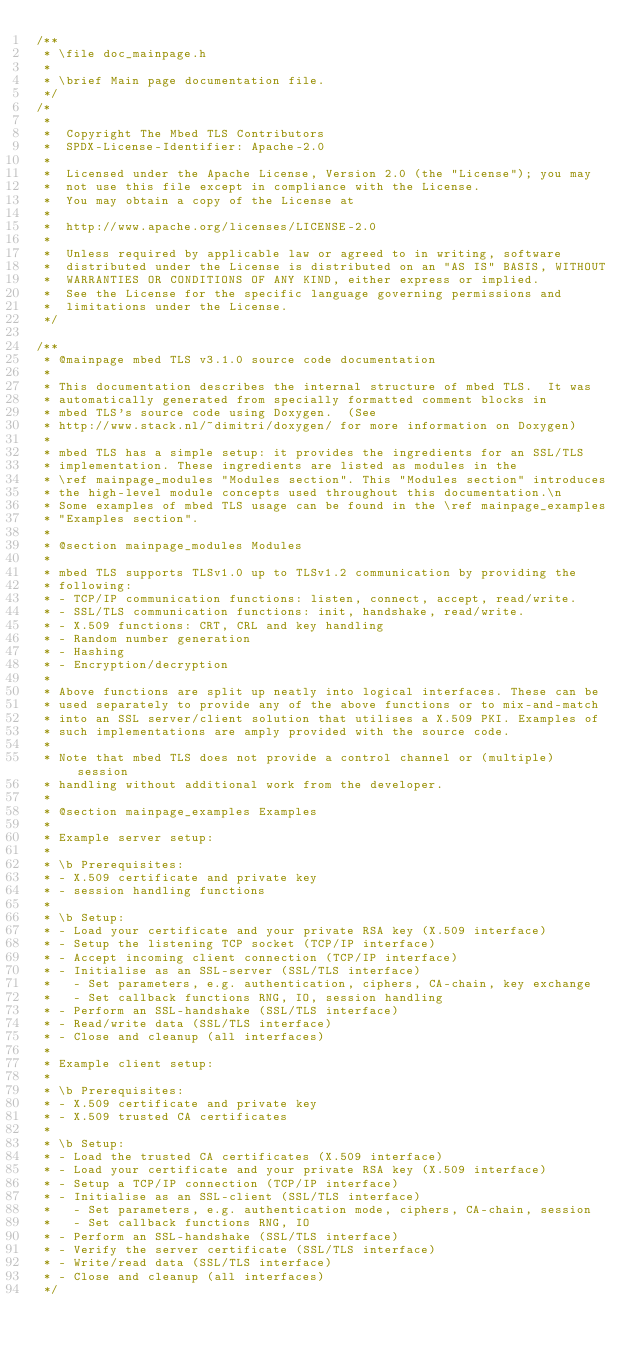Convert code to text. <code><loc_0><loc_0><loc_500><loc_500><_C_>/**
 * \file doc_mainpage.h
 *
 * \brief Main page documentation file.
 */
/*
 *
 *  Copyright The Mbed TLS Contributors
 *  SPDX-License-Identifier: Apache-2.0
 *
 *  Licensed under the Apache License, Version 2.0 (the "License"); you may
 *  not use this file except in compliance with the License.
 *  You may obtain a copy of the License at
 *
 *  http://www.apache.org/licenses/LICENSE-2.0
 *
 *  Unless required by applicable law or agreed to in writing, software
 *  distributed under the License is distributed on an "AS IS" BASIS, WITHOUT
 *  WARRANTIES OR CONDITIONS OF ANY KIND, either express or implied.
 *  See the License for the specific language governing permissions and
 *  limitations under the License.
 */

/**
 * @mainpage mbed TLS v3.1.0 source code documentation
 *
 * This documentation describes the internal structure of mbed TLS.  It was
 * automatically generated from specially formatted comment blocks in
 * mbed TLS's source code using Doxygen.  (See
 * http://www.stack.nl/~dimitri/doxygen/ for more information on Doxygen)
 *
 * mbed TLS has a simple setup: it provides the ingredients for an SSL/TLS
 * implementation. These ingredients are listed as modules in the
 * \ref mainpage_modules "Modules section". This "Modules section" introduces
 * the high-level module concepts used throughout this documentation.\n
 * Some examples of mbed TLS usage can be found in the \ref mainpage_examples
 * "Examples section".
 *
 * @section mainpage_modules Modules
 *
 * mbed TLS supports TLSv1.0 up to TLSv1.2 communication by providing the
 * following:
 * - TCP/IP communication functions: listen, connect, accept, read/write.
 * - SSL/TLS communication functions: init, handshake, read/write.
 * - X.509 functions: CRT, CRL and key handling
 * - Random number generation
 * - Hashing
 * - Encryption/decryption
 *
 * Above functions are split up neatly into logical interfaces. These can be
 * used separately to provide any of the above functions or to mix-and-match
 * into an SSL server/client solution that utilises a X.509 PKI. Examples of
 * such implementations are amply provided with the source code.
 *
 * Note that mbed TLS does not provide a control channel or (multiple) session
 * handling without additional work from the developer.
 *
 * @section mainpage_examples Examples
 *
 * Example server setup:
 *
 * \b Prerequisites:
 * - X.509 certificate and private key
 * - session handling functions
 *
 * \b Setup:
 * - Load your certificate and your private RSA key (X.509 interface)
 * - Setup the listening TCP socket (TCP/IP interface)
 * - Accept incoming client connection (TCP/IP interface)
 * - Initialise as an SSL-server (SSL/TLS interface)
 *   - Set parameters, e.g. authentication, ciphers, CA-chain, key exchange
 *   - Set callback functions RNG, IO, session handling
 * - Perform an SSL-handshake (SSL/TLS interface)
 * - Read/write data (SSL/TLS interface)
 * - Close and cleanup (all interfaces)
 *
 * Example client setup:
 *
 * \b Prerequisites:
 * - X.509 certificate and private key
 * - X.509 trusted CA certificates
 *
 * \b Setup:
 * - Load the trusted CA certificates (X.509 interface)
 * - Load your certificate and your private RSA key (X.509 interface)
 * - Setup a TCP/IP connection (TCP/IP interface)
 * - Initialise as an SSL-client (SSL/TLS interface)
 *   - Set parameters, e.g. authentication mode, ciphers, CA-chain, session
 *   - Set callback functions RNG, IO
 * - Perform an SSL-handshake (SSL/TLS interface)
 * - Verify the server certificate (SSL/TLS interface)
 * - Write/read data (SSL/TLS interface)
 * - Close and cleanup (all interfaces)
 */
</code> 